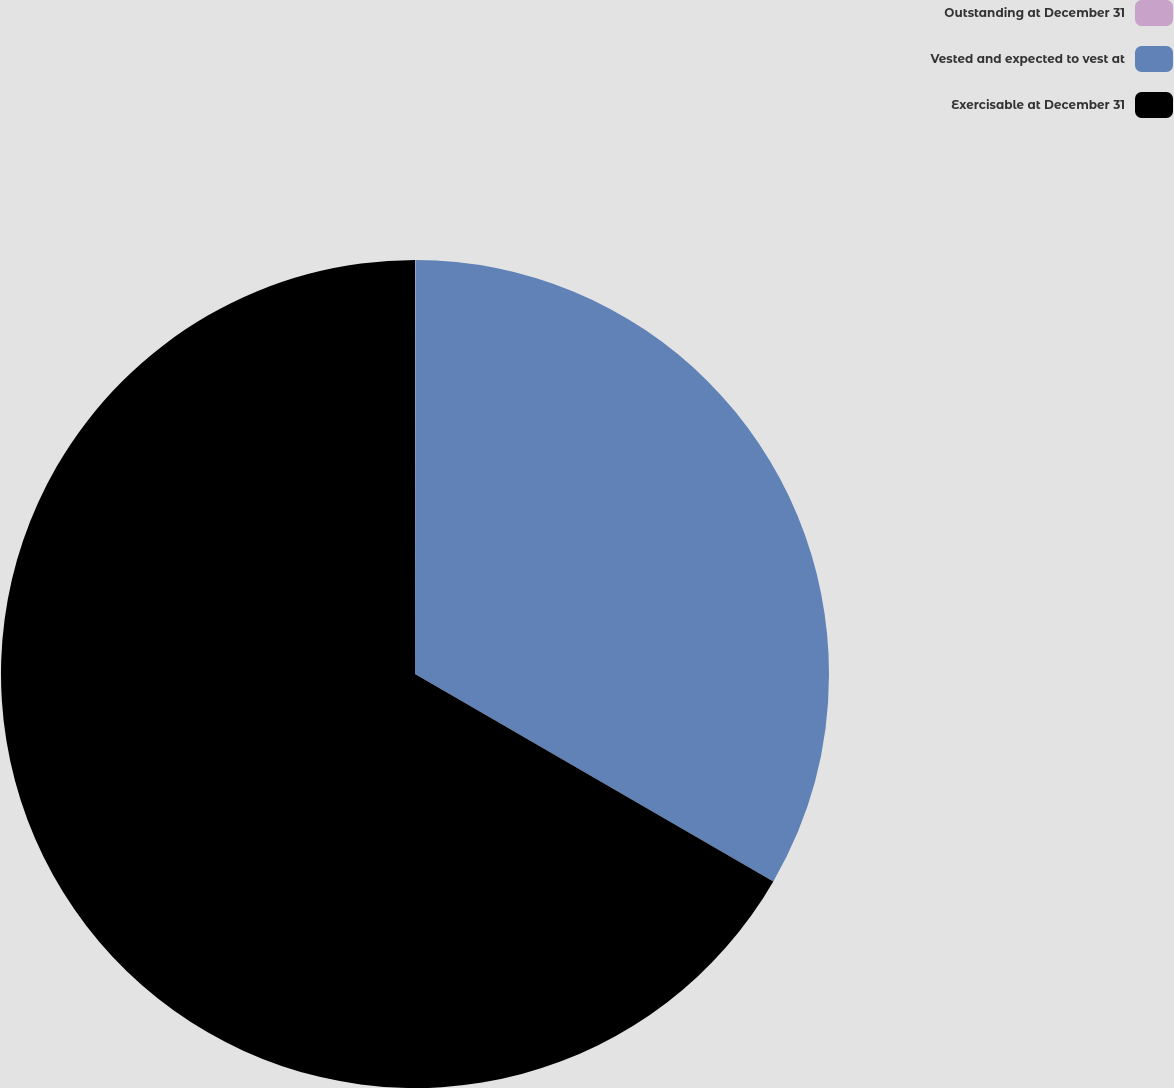Convert chart. <chart><loc_0><loc_0><loc_500><loc_500><pie_chart><fcel>Outstanding at December 31<fcel>Vested and expected to vest at<fcel>Exercisable at December 31<nl><fcel>0.02%<fcel>33.33%<fcel>66.65%<nl></chart> 